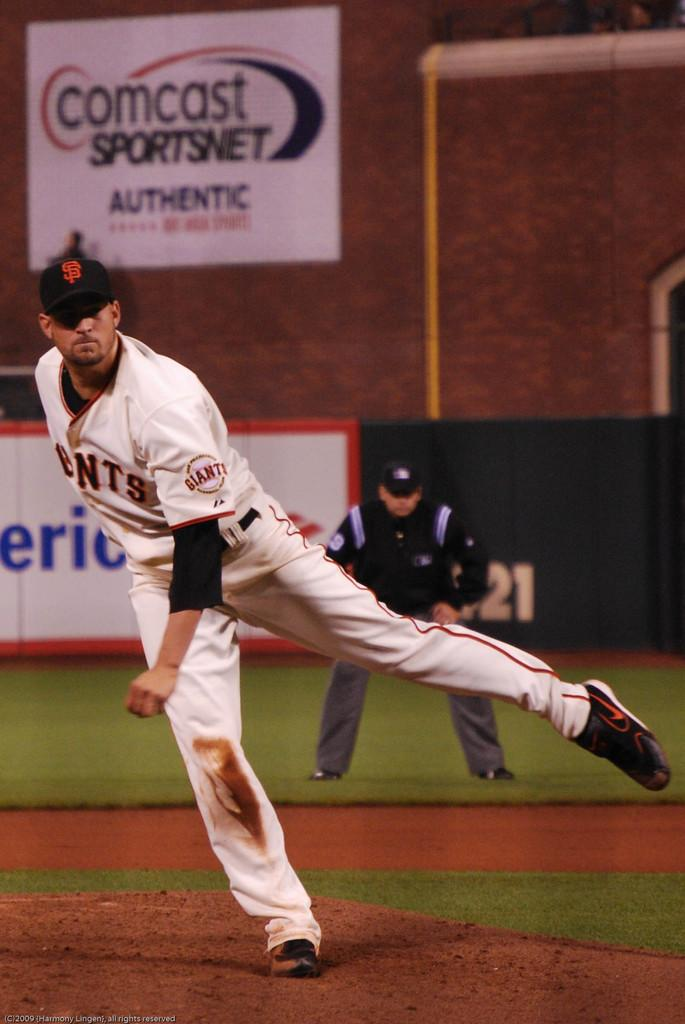<image>
Present a compact description of the photo's key features. The pitcher of a baseball team has the giants logo on his arm. 